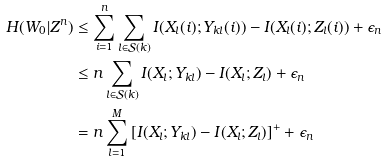<formula> <loc_0><loc_0><loc_500><loc_500>H ( W _ { 0 } | Z ^ { n } ) & \leq \sum _ { i = 1 } ^ { n } \sum _ { l \in \mathcal { S } ( k ) } I ( X _ { l } ( i ) ; Y _ { k l } ( i ) ) - I ( X _ { l } ( i ) ; Z _ { l } ( i ) ) + \epsilon _ { n } \\ & \leq n \sum _ { l \in \mathcal { S } ( k ) } I ( X _ { l } ; Y _ { k l } ) - I ( X _ { l } ; Z _ { l } ) + \epsilon _ { n } \\ & = n \sum _ { l = 1 } ^ { M } \left [ I ( X _ { l } ; Y _ { k l } ) - I ( X _ { l } ; Z _ { l } ) \right ] ^ { + } + \epsilon _ { n }</formula> 